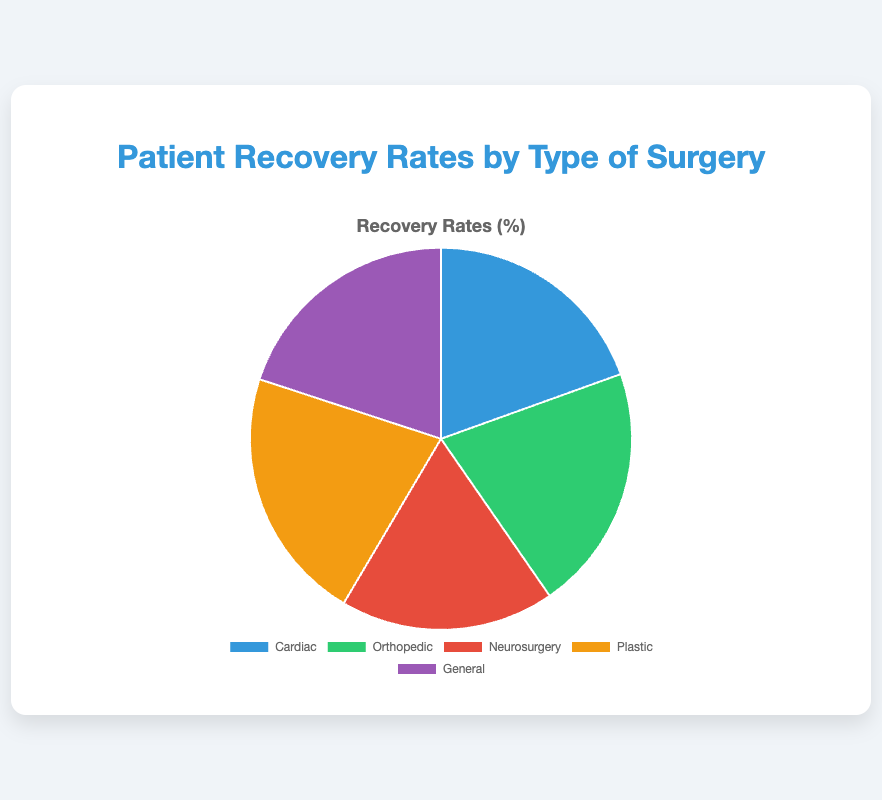Which type of surgery has the highest recovery rate? By looking at the pie chart, identify the slice with the largest value label. "Plastic" has the highest recovery rate at 95%.
Answer: Plastic Which hospital has a recovery rate of 88% and what type of surgery corresponds to it? Identify the pie slice labeled 88% in the chart, then find the corresponding data entry. Cleveland Clinic has an 88% recovery rate, which is for general surgery.
Answer: Cleveland Clinic, General What is the difference in recovery rates between the type of surgery with the highest and the lowest recovery rates? Find the highest and lowest values in the chart: 95% (Plastic) and 80% (Neurosurgery). The difference is 95% - 80% = 15%.
Answer: 15% What is the total combined recovery rate for Cardiac and Orthopedic surgeries? Add the recovery rates of Cardiac (86%) and Orthopedic (92%) from the chart: 86 + 92 = 178.
Answer: 178% What color is the slice that represents Neurosurgery? Look at the color of the slice labeled Neurosurgery with an 80% recovery rate. The color is red.
Answer: red How much higher is the recovery rate for Orthopedic surgeries compared to Cardiac surgeries? Subtract the recovery rate of Cardiac surgeries from Orthopedic surgeries: 92% - 86% = 6%.
Answer: 6% Which type of surgery has the second highest recovery rate? Identify the second largest slice after Plastic (95%); the second highest is Orthopedic with 92%.
Answer: Orthopedic If you combine the recovery rates for Neurosurgery and General surgeries, what is the total? Add the recovery rates of Neurosurgery (80%) and General (88%): 80 + 88 = 168.
Answer: 168% Which type of surgery has a recovery rate closest to 90%? Look at the pie chart, and compare recovery rates close to 90%. The closest is General surgery with 88%.
Answer: General 